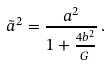Convert formula to latex. <formula><loc_0><loc_0><loc_500><loc_500>\tilde { a } ^ { 2 } = \frac { a ^ { 2 } } { 1 + \frac { 4 b ^ { 2 } } { G } } \, .</formula> 